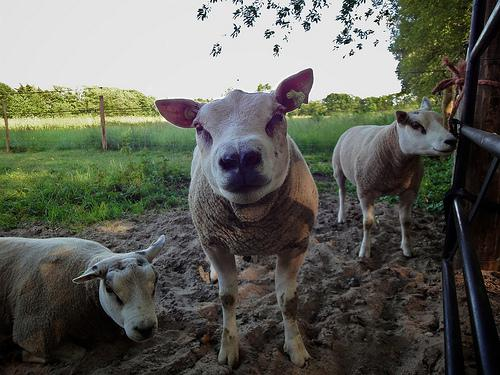Question: how many animals are in this picture?
Choices:
A. Four.
B. Three.
C. Two.
D. One.
Answer with the letter. Answer: B Question: what is in the animal's ear?
Choices:
A. Wax.
B. An ear tag.
C. A light.
D. A hearing aid.
Answer with the letter. Answer: B Question: what kind of animals are these?
Choices:
A. Cows.
B. Sheep.
C. Bears.
D. Lions.
Answer with the letter. Answer: B Question: how is the back one positioned?
Choices:
A. Sitting.
B. Lying.
C. Crouched.
D. Standing.
Answer with the letter. Answer: D Question: what is next to the back sheep?
Choices:
A. Black fence.
B. Farmer.
C. Kids.
D. Grandma.
Answer with the letter. Answer: A Question: when was this photo taken?
Choices:
A. At night.
B. During the day.
C. In the afternoon.
D. At dawn.
Answer with the letter. Answer: B 